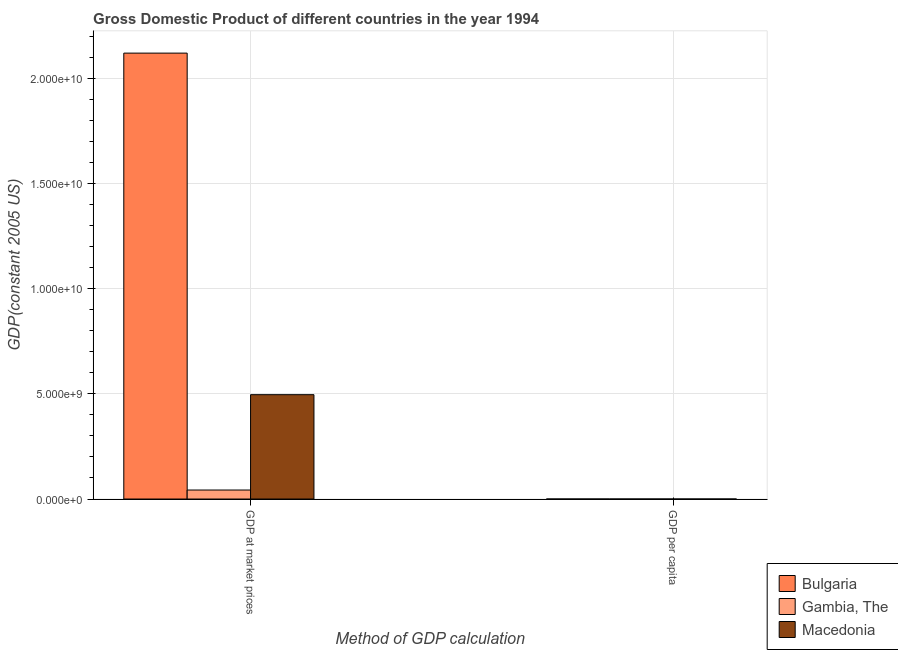How many groups of bars are there?
Your response must be concise. 2. How many bars are there on the 1st tick from the left?
Your answer should be very brief. 3. What is the label of the 2nd group of bars from the left?
Give a very brief answer. GDP per capita. What is the gdp at market prices in Gambia, The?
Your response must be concise. 4.28e+08. Across all countries, what is the maximum gdp per capita?
Keep it short and to the point. 2535.57. Across all countries, what is the minimum gdp per capita?
Make the answer very short. 412.99. In which country was the gdp per capita maximum?
Ensure brevity in your answer.  Macedonia. In which country was the gdp at market prices minimum?
Offer a very short reply. Gambia, The. What is the total gdp at market prices in the graph?
Ensure brevity in your answer.  2.66e+1. What is the difference between the gdp per capita in Macedonia and that in Gambia, The?
Provide a succinct answer. 2122.58. What is the difference between the gdp at market prices in Gambia, The and the gdp per capita in Macedonia?
Provide a short and direct response. 4.28e+08. What is the average gdp per capita per country?
Your response must be concise. 1819.55. What is the difference between the gdp at market prices and gdp per capita in Macedonia?
Give a very brief answer. 4.96e+09. What is the ratio of the gdp per capita in Bulgaria to that in Macedonia?
Ensure brevity in your answer.  0.99. What does the 2nd bar from the left in GDP per capita represents?
Provide a short and direct response. Gambia, The. What does the 2nd bar from the right in GDP per capita represents?
Ensure brevity in your answer.  Gambia, The. Are all the bars in the graph horizontal?
Provide a short and direct response. No. What is the difference between two consecutive major ticks on the Y-axis?
Provide a short and direct response. 5.00e+09. Are the values on the major ticks of Y-axis written in scientific E-notation?
Keep it short and to the point. Yes. Does the graph contain grids?
Your answer should be compact. Yes. Where does the legend appear in the graph?
Offer a terse response. Bottom right. How are the legend labels stacked?
Provide a succinct answer. Vertical. What is the title of the graph?
Make the answer very short. Gross Domestic Product of different countries in the year 1994. Does "Senegal" appear as one of the legend labels in the graph?
Offer a terse response. No. What is the label or title of the X-axis?
Offer a very short reply. Method of GDP calculation. What is the label or title of the Y-axis?
Your response must be concise. GDP(constant 2005 US). What is the GDP(constant 2005 US) of Bulgaria in GDP at market prices?
Ensure brevity in your answer.  2.12e+1. What is the GDP(constant 2005 US) in Gambia, The in GDP at market prices?
Keep it short and to the point. 4.28e+08. What is the GDP(constant 2005 US) of Macedonia in GDP at market prices?
Give a very brief answer. 4.96e+09. What is the GDP(constant 2005 US) of Bulgaria in GDP per capita?
Your response must be concise. 2510.1. What is the GDP(constant 2005 US) in Gambia, The in GDP per capita?
Your answer should be compact. 412.99. What is the GDP(constant 2005 US) of Macedonia in GDP per capita?
Keep it short and to the point. 2535.57. Across all Method of GDP calculation, what is the maximum GDP(constant 2005 US) in Bulgaria?
Your answer should be very brief. 2.12e+1. Across all Method of GDP calculation, what is the maximum GDP(constant 2005 US) in Gambia, The?
Provide a succinct answer. 4.28e+08. Across all Method of GDP calculation, what is the maximum GDP(constant 2005 US) of Macedonia?
Provide a succinct answer. 4.96e+09. Across all Method of GDP calculation, what is the minimum GDP(constant 2005 US) in Bulgaria?
Offer a very short reply. 2510.1. Across all Method of GDP calculation, what is the minimum GDP(constant 2005 US) of Gambia, The?
Provide a succinct answer. 412.99. Across all Method of GDP calculation, what is the minimum GDP(constant 2005 US) in Macedonia?
Provide a succinct answer. 2535.57. What is the total GDP(constant 2005 US) of Bulgaria in the graph?
Keep it short and to the point. 2.12e+1. What is the total GDP(constant 2005 US) in Gambia, The in the graph?
Provide a short and direct response. 4.28e+08. What is the total GDP(constant 2005 US) in Macedonia in the graph?
Offer a very short reply. 4.96e+09. What is the difference between the GDP(constant 2005 US) in Bulgaria in GDP at market prices and that in GDP per capita?
Offer a very short reply. 2.12e+1. What is the difference between the GDP(constant 2005 US) in Gambia, The in GDP at market prices and that in GDP per capita?
Make the answer very short. 4.28e+08. What is the difference between the GDP(constant 2005 US) in Macedonia in GDP at market prices and that in GDP per capita?
Ensure brevity in your answer.  4.96e+09. What is the difference between the GDP(constant 2005 US) of Bulgaria in GDP at market prices and the GDP(constant 2005 US) of Gambia, The in GDP per capita?
Ensure brevity in your answer.  2.12e+1. What is the difference between the GDP(constant 2005 US) of Bulgaria in GDP at market prices and the GDP(constant 2005 US) of Macedonia in GDP per capita?
Ensure brevity in your answer.  2.12e+1. What is the difference between the GDP(constant 2005 US) in Gambia, The in GDP at market prices and the GDP(constant 2005 US) in Macedonia in GDP per capita?
Your answer should be compact. 4.28e+08. What is the average GDP(constant 2005 US) in Bulgaria per Method of GDP calculation?
Provide a short and direct response. 1.06e+1. What is the average GDP(constant 2005 US) in Gambia, The per Method of GDP calculation?
Make the answer very short. 2.14e+08. What is the average GDP(constant 2005 US) in Macedonia per Method of GDP calculation?
Provide a short and direct response. 2.48e+09. What is the difference between the GDP(constant 2005 US) in Bulgaria and GDP(constant 2005 US) in Gambia, The in GDP at market prices?
Your response must be concise. 2.08e+1. What is the difference between the GDP(constant 2005 US) of Bulgaria and GDP(constant 2005 US) of Macedonia in GDP at market prices?
Ensure brevity in your answer.  1.62e+1. What is the difference between the GDP(constant 2005 US) of Gambia, The and GDP(constant 2005 US) of Macedonia in GDP at market prices?
Provide a succinct answer. -4.53e+09. What is the difference between the GDP(constant 2005 US) of Bulgaria and GDP(constant 2005 US) of Gambia, The in GDP per capita?
Keep it short and to the point. 2097.11. What is the difference between the GDP(constant 2005 US) in Bulgaria and GDP(constant 2005 US) in Macedonia in GDP per capita?
Offer a terse response. -25.47. What is the difference between the GDP(constant 2005 US) in Gambia, The and GDP(constant 2005 US) in Macedonia in GDP per capita?
Give a very brief answer. -2122.58. What is the ratio of the GDP(constant 2005 US) in Bulgaria in GDP at market prices to that in GDP per capita?
Make the answer very short. 8.44e+06. What is the ratio of the GDP(constant 2005 US) of Gambia, The in GDP at market prices to that in GDP per capita?
Offer a very short reply. 1.04e+06. What is the ratio of the GDP(constant 2005 US) in Macedonia in GDP at market prices to that in GDP per capita?
Ensure brevity in your answer.  1.96e+06. What is the difference between the highest and the second highest GDP(constant 2005 US) of Bulgaria?
Offer a terse response. 2.12e+1. What is the difference between the highest and the second highest GDP(constant 2005 US) of Gambia, The?
Your answer should be compact. 4.28e+08. What is the difference between the highest and the second highest GDP(constant 2005 US) of Macedonia?
Offer a terse response. 4.96e+09. What is the difference between the highest and the lowest GDP(constant 2005 US) of Bulgaria?
Your answer should be very brief. 2.12e+1. What is the difference between the highest and the lowest GDP(constant 2005 US) in Gambia, The?
Offer a terse response. 4.28e+08. What is the difference between the highest and the lowest GDP(constant 2005 US) in Macedonia?
Offer a very short reply. 4.96e+09. 